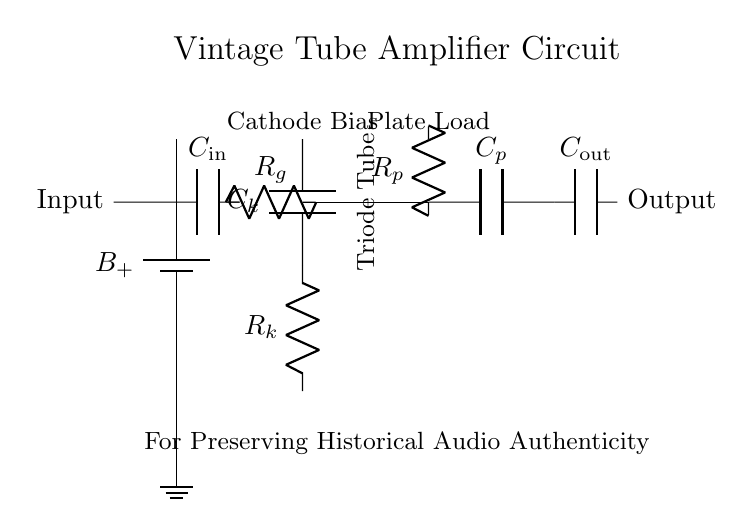What is the power supply voltage type? The power supply voltage type is DC, indicated by the battery symbol marked as B+.
Answer: DC What component is connected to the input? The component connected to the input is a resistor, labeled as Rg, connected to the capacitor Cin.
Answer: Resistor What is the role of the triode tube in this circuit? The triode tube acts as an amplifier, and it is marked clearly in the diagram at the center.
Answer: Amplifier What type of capacitor is in the output stage? The type of capacitor in the output stage is labeled as Cout, which is a coupling capacitor.
Answer: Coupling How many resistors are present in the circuit? There are three resistors in total: Rk, Rg, and Rp.
Answer: Three What is the purpose of the capacitor Ck? The capacitor Ck is used for cathode biasing in the circuit, which enhances the linearity of the tube amplifier.
Answer: Cathode biasing What is the output signal described as? The output signal is described as having authenticity, related to the preservation of historical audio recordings.
Answer: Historical audio authenticity 